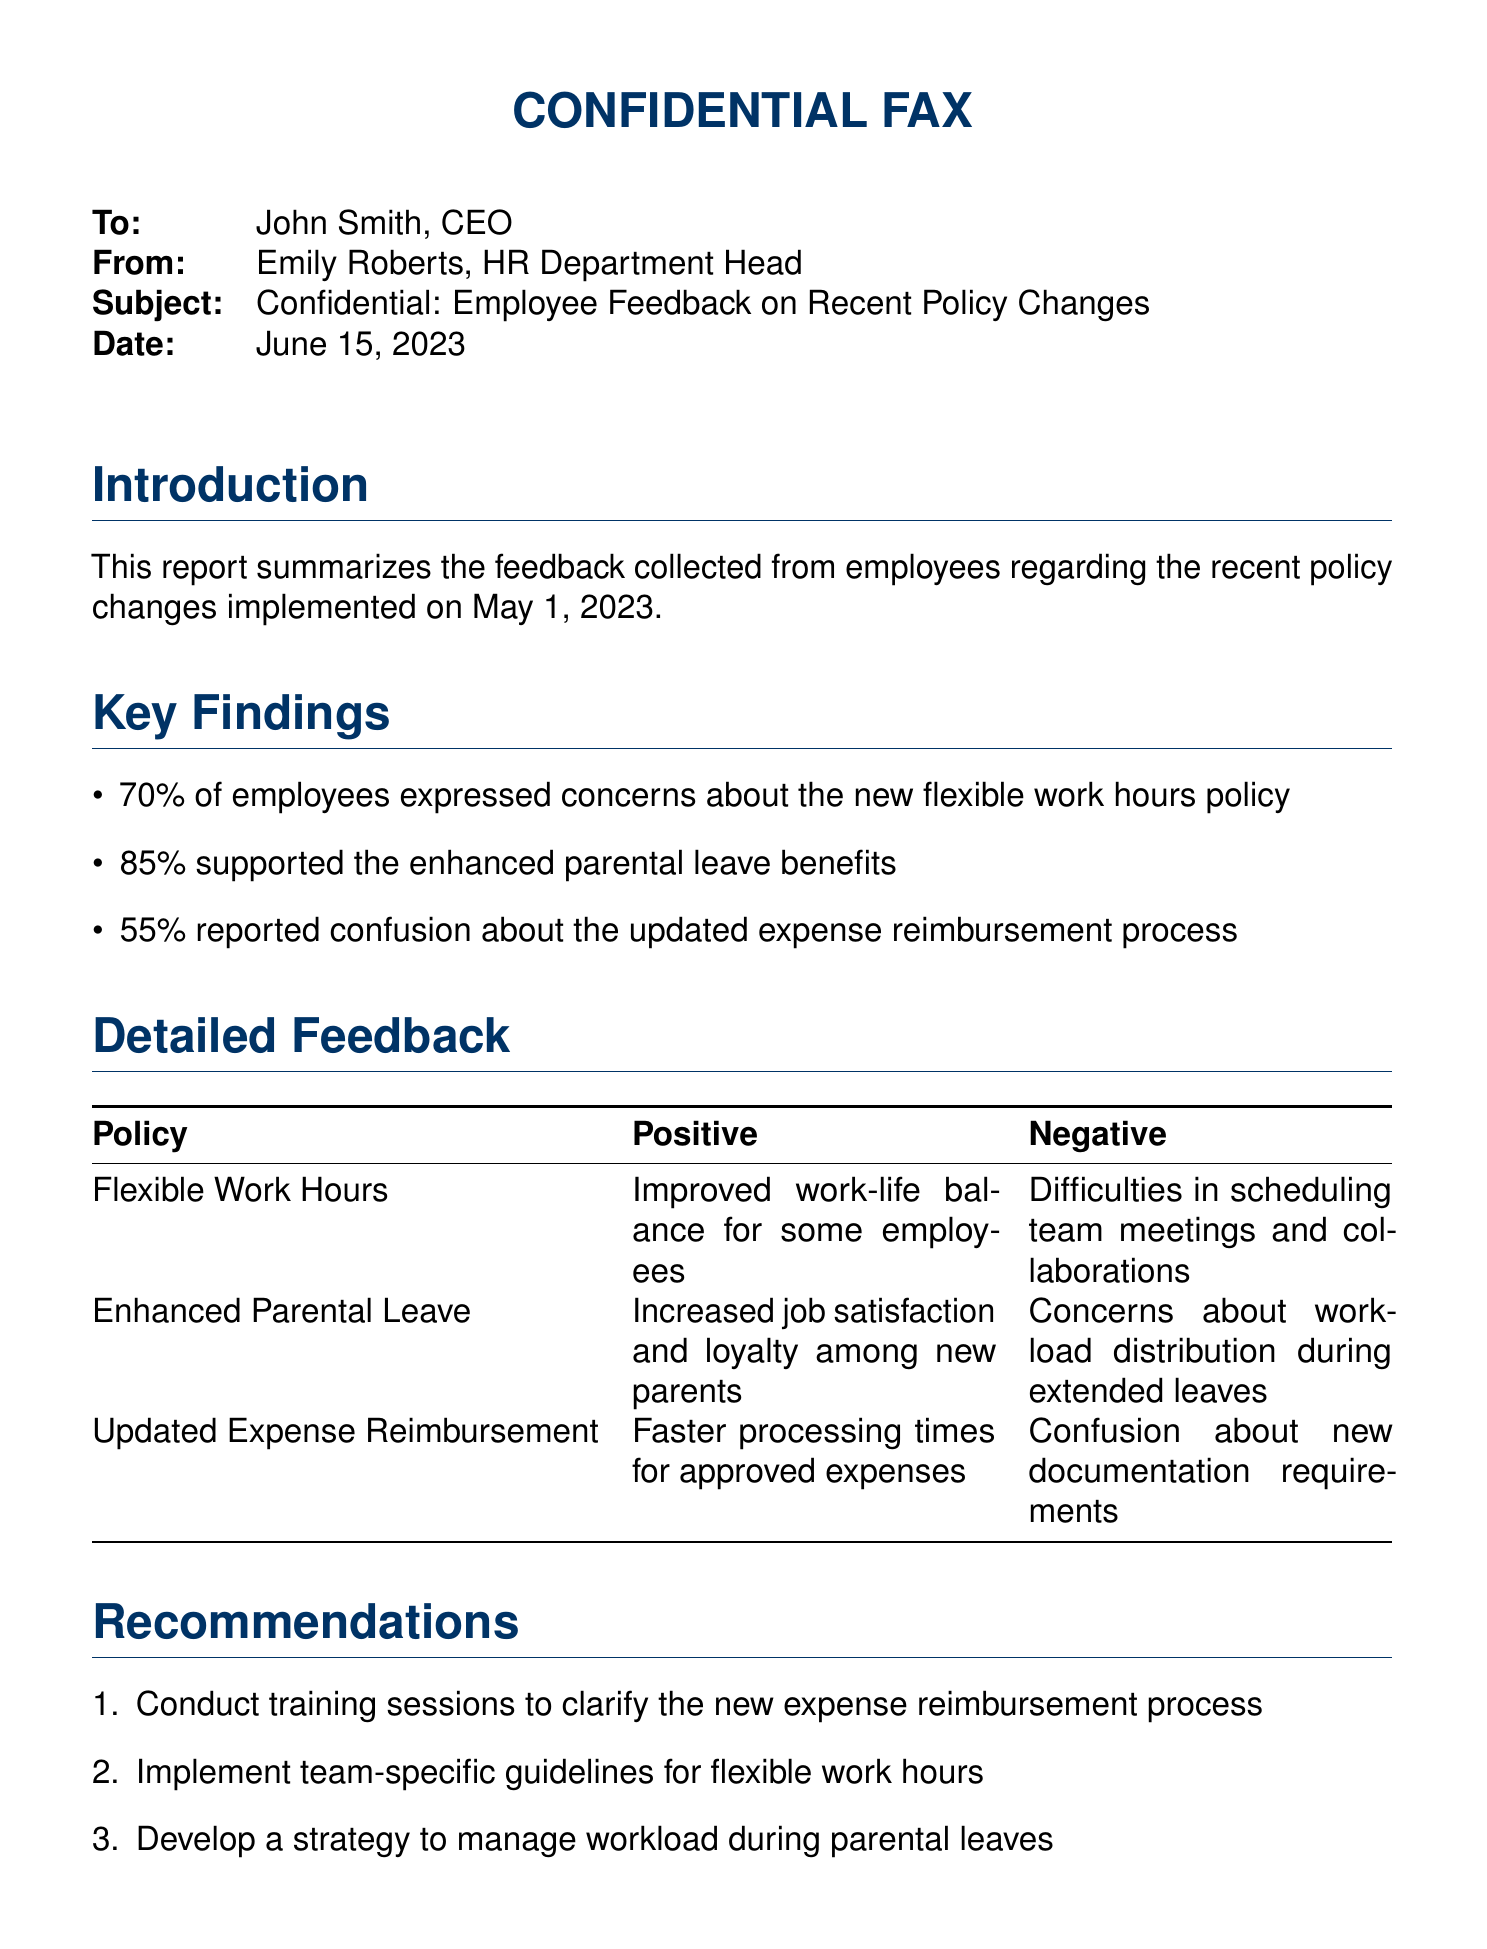What is the percentage of employees concerned about the flexible work hours policy? The document states that 70% of employees expressed concerns about the new flexible work hours policy.
Answer: 70% What date was the employee feedback report dated? The date mentioned in the fax is June 15, 2023.
Answer: June 15, 2023 What is the main positive feedback regarding the enhanced parental leave? The improved job satisfaction and loyalty among new parents is highlighted as a positive outcome.
Answer: Increased job satisfaction and loyalty What recommendation is made regarding the updated expense reimbursement process? The recommendation suggests conducting training sessions to clarify the new expense reimbursement process.
Answer: Conduct training sessions How many policies showed high employee support compared to concerns? The report indicates that 85% supported the enhanced parental leave benefits, which is higher than the other policies' concerns.
Answer: One policy What is one negative aspect of the flexible work hours mentioned? The document notes difficulties in scheduling team meetings and collaborations as a negative aspect of the policy.
Answer: Difficulties in scheduling Who is the sender of the fax? The sender of the fax is identified as Emily Roberts, HR Department Head.
Answer: Emily Roberts What is the main reason for confusion related to the updated expense reimbursement? The confusion arises from new documentation requirements that employees are uncertain about.
Answer: New documentation requirements 